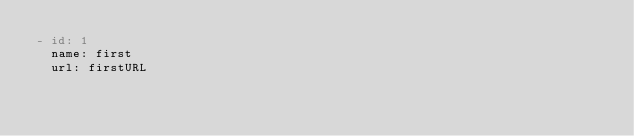Convert code to text. <code><loc_0><loc_0><loc_500><loc_500><_YAML_>- id: 1
  name: first
  url: firstURL</code> 